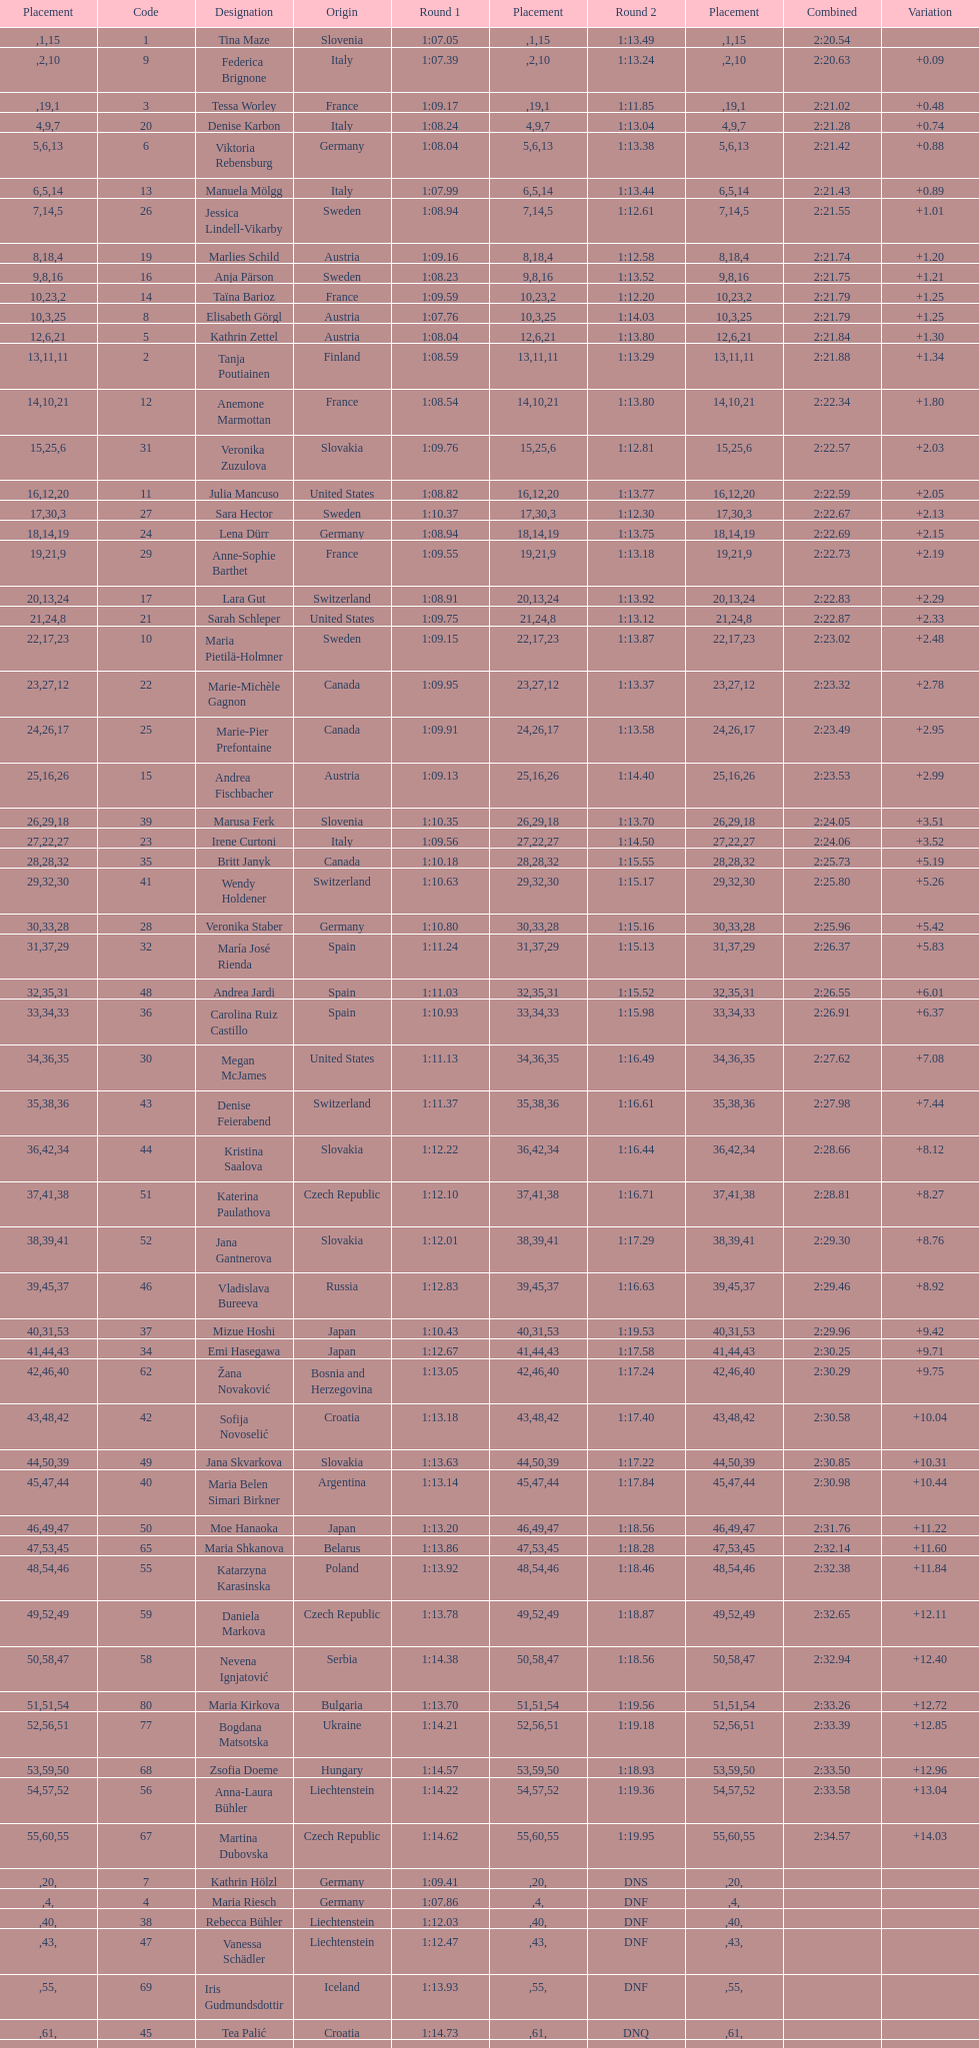What is the last nation to be ranked? Czech Republic. 